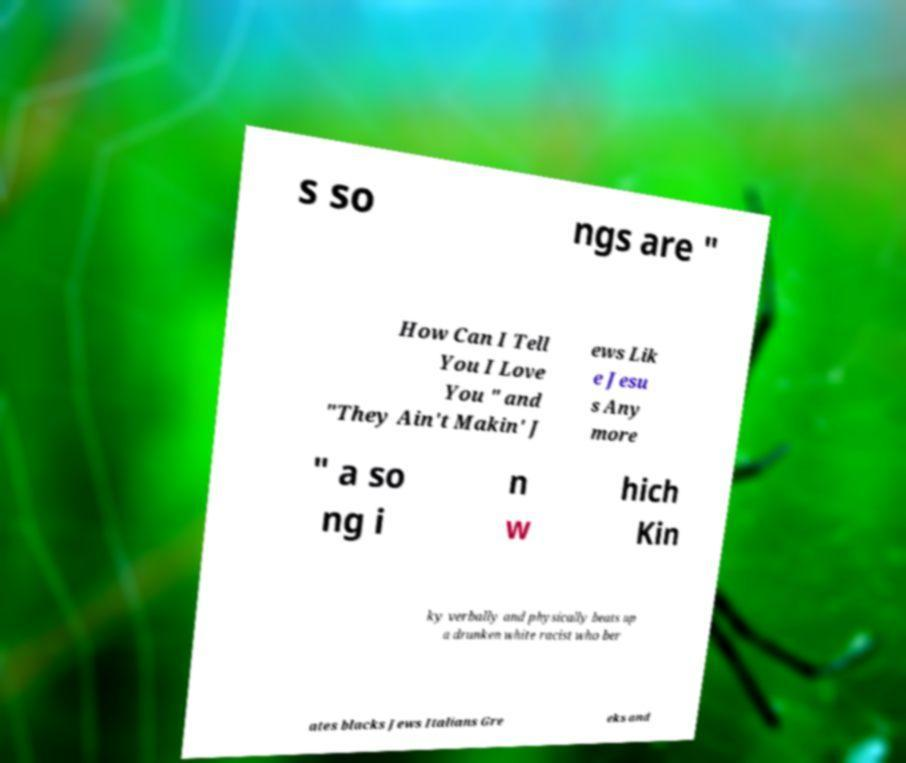What messages or text are displayed in this image? I need them in a readable, typed format. s so ngs are " How Can I Tell You I Love You " and "They Ain't Makin' J ews Lik e Jesu s Any more " a so ng i n w hich Kin ky verbally and physically beats up a drunken white racist who ber ates blacks Jews Italians Gre eks and 